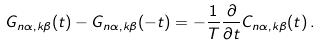<formula> <loc_0><loc_0><loc_500><loc_500>G _ { { n } \alpha , { k } \beta } ( t ) - G _ { { n } \alpha , { k } \beta } ( - t ) = - \frac { 1 } { T } \frac { \partial } { \partial t } C _ { { n } \alpha , { k } \beta } ( t ) \, .</formula> 